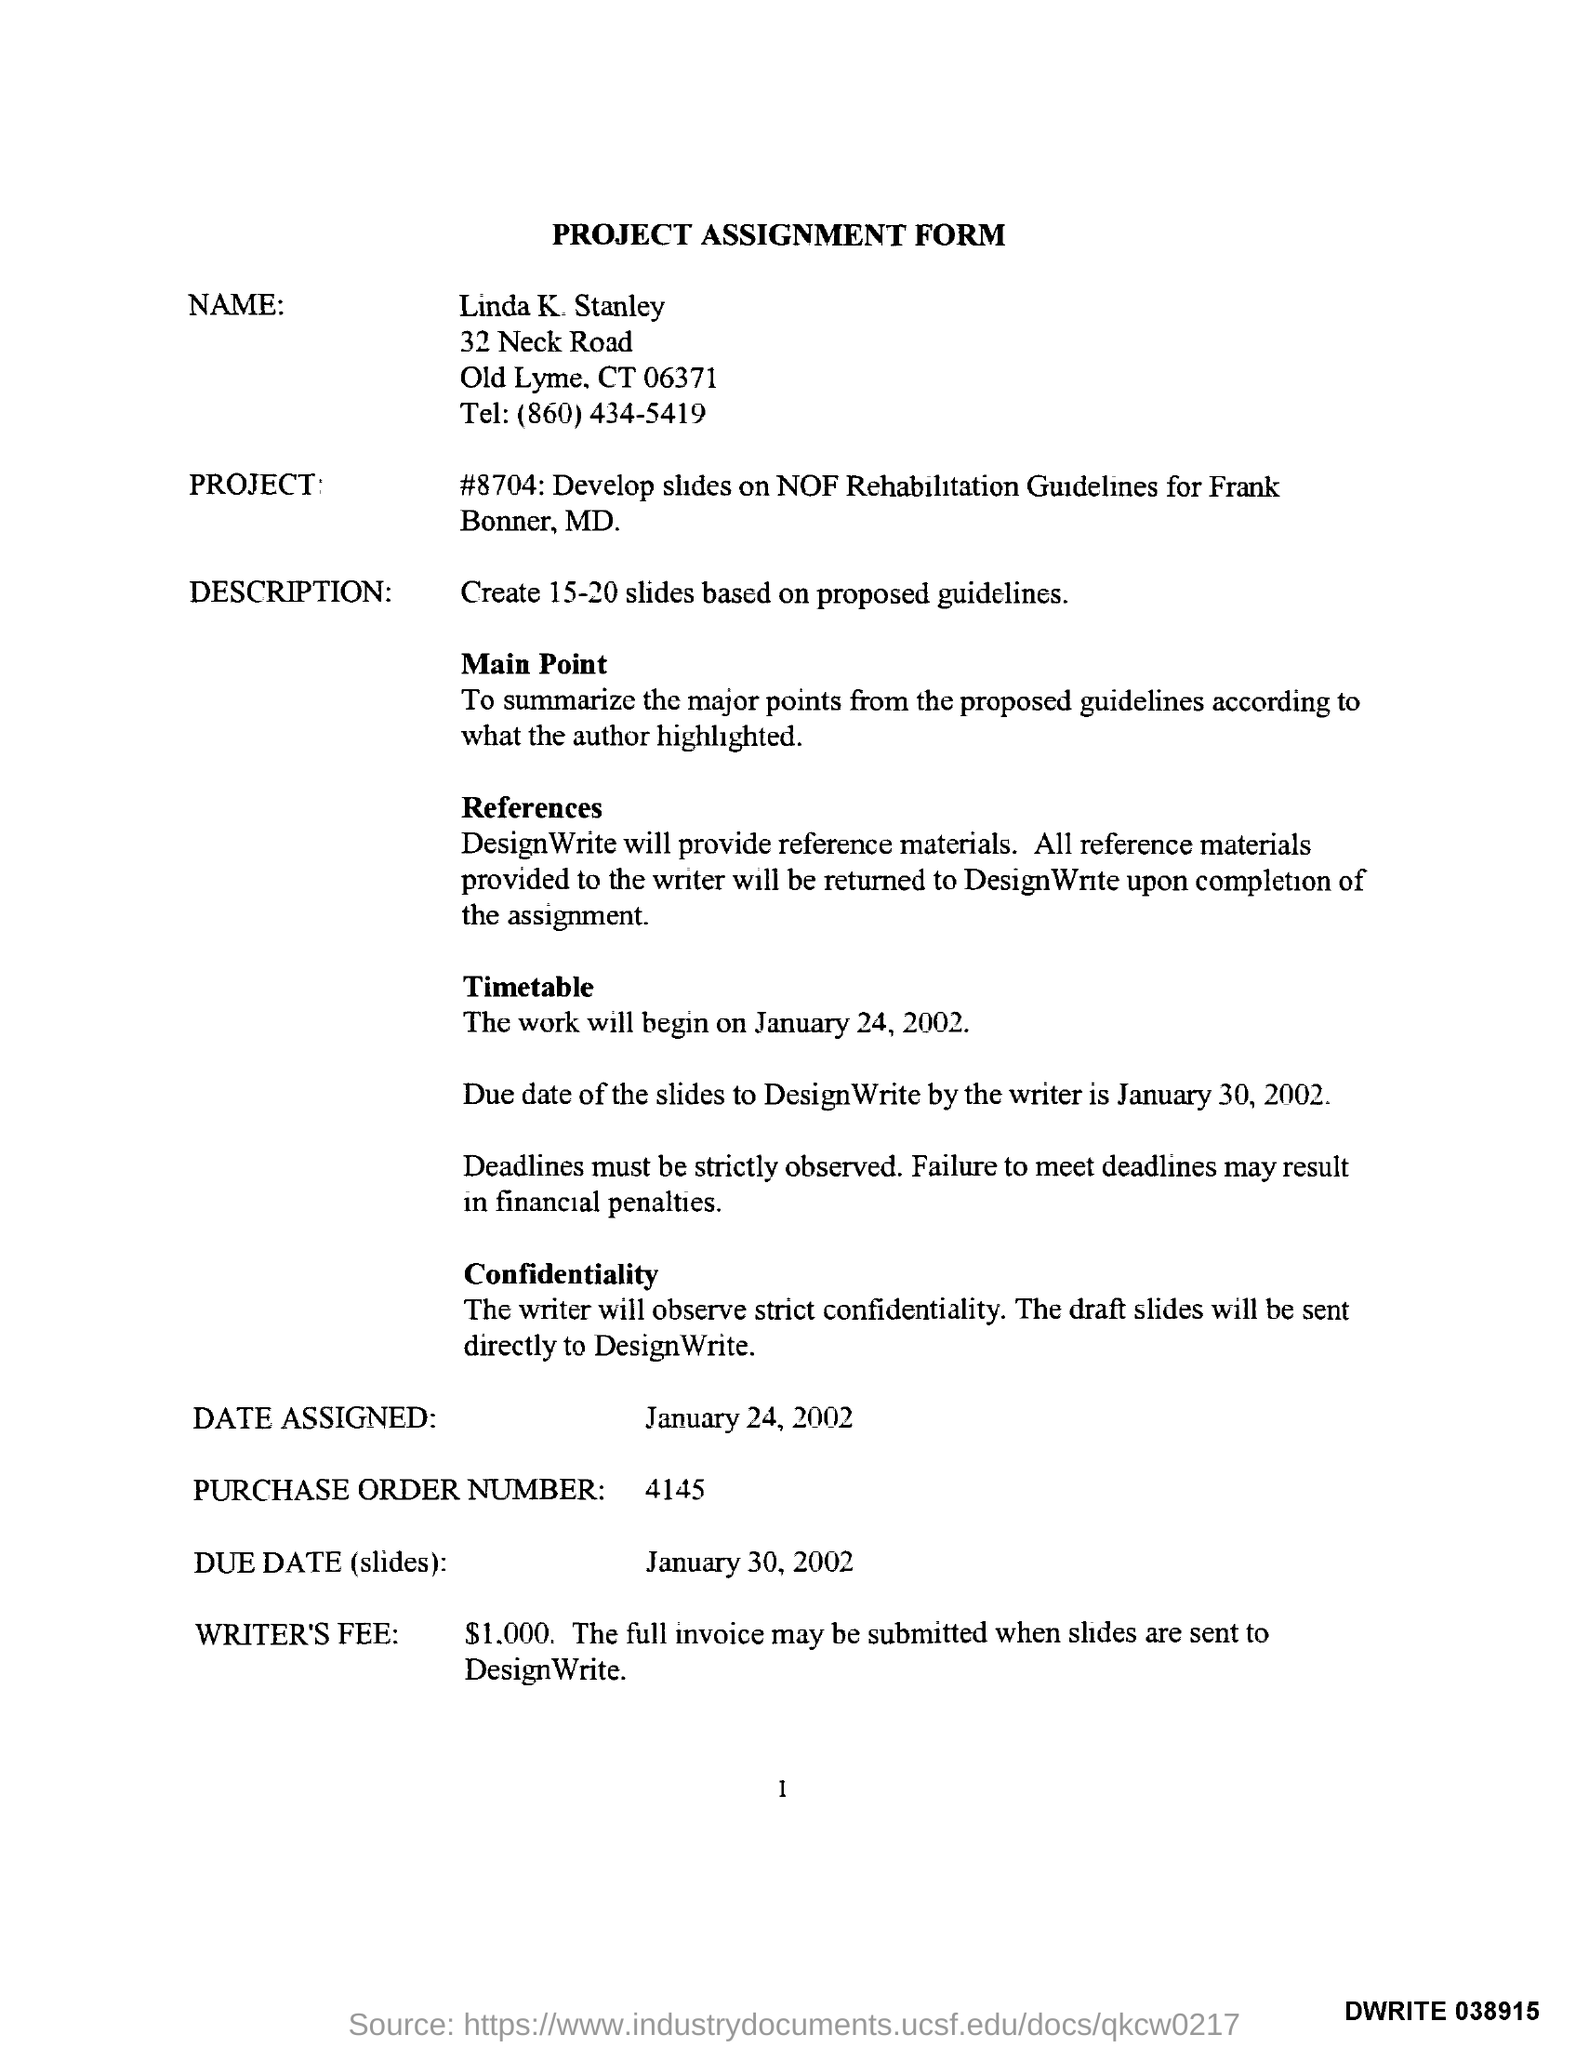What is the title of the document?
Offer a very short reply. Project Assignment Form. What is the purchase order number?
Your answer should be compact. 4145. What is the due date for slides?
Give a very brief answer. January 30, 2002. What is the telephone number of linda?
Provide a succinct answer. (860)434-5419. 